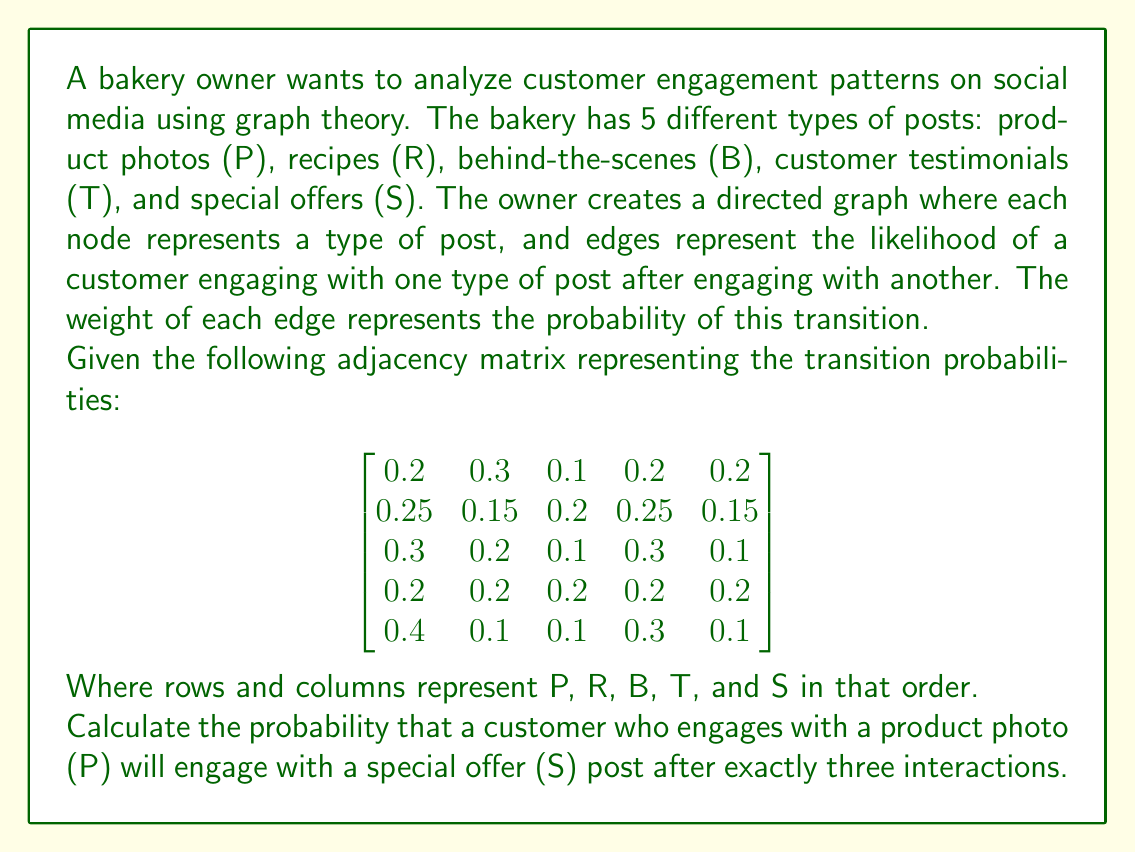Can you answer this question? To solve this problem, we need to use the concept of matrix multiplication in graph theory. The given matrix represents the probability of transitioning from one type of post to another in a single step.

To find the probability of a specific path after exactly three interactions, we need to raise the matrix to the power of 3. This is because each multiplication represents one step in the path.

Let's call our original matrix A. We need to calculate $A^3$.

Step 1: Calculate $A^2$
$$A^2 = A \times A$$

Step 2: Calculate $A^3$
$$A^3 = A^2 \times A$$

Step 3: After calculating $A^3$, we'll have a matrix that represents the probabilities of going from any node to any other node in exactly three steps.

Step 4: To find the probability of going from P to S in exactly three steps, we need to look at the element in the first row (P) and fifth column (S) of $A^3$.

Performing these calculations:

$A^2$ =
$$
\begin{bmatrix}
0.255 & 0.200 & 0.150 & 0.245 & 0.150 \\
0.2375 & 0.2125 & 0.1625 & 0.2375 & 0.1500 \\
0.2450 & 0.2150 & 0.1550 & 0.2450 & 0.1400 \\
0.2700 & 0.1900 & 0.1400 & 0.2500 & 0.1500 \\
0.2650 & 0.2250 & 0.1450 & 0.2550 & 0.1600
\end{bmatrix}
$$

$A^3$ =
$$
\begin{bmatrix}
0.25025 & 0.20500 & 0.15250 & 0.24225 & 0.15000 \\
0.25013 & 0.20488 & 0.15238 & 0.24225 & 0.15038 \\
0.25200 & 0.20550 & 0.15225 & 0.24300 & 0.14725 \\
0.25250 & 0.20500 & 0.15250 & 0.24250 & 0.14750 \\
0.25075 & 0.20575 & 0.15225 & 0.24250 & 0.14875
\end{bmatrix}
$$

The probability we're looking for is in the first row, fifth column of $A^3$.
Answer: The probability that a customer who engages with a product photo (P) will engage with a special offer (S) post after exactly three interactions is 0.15000 or 15%. 